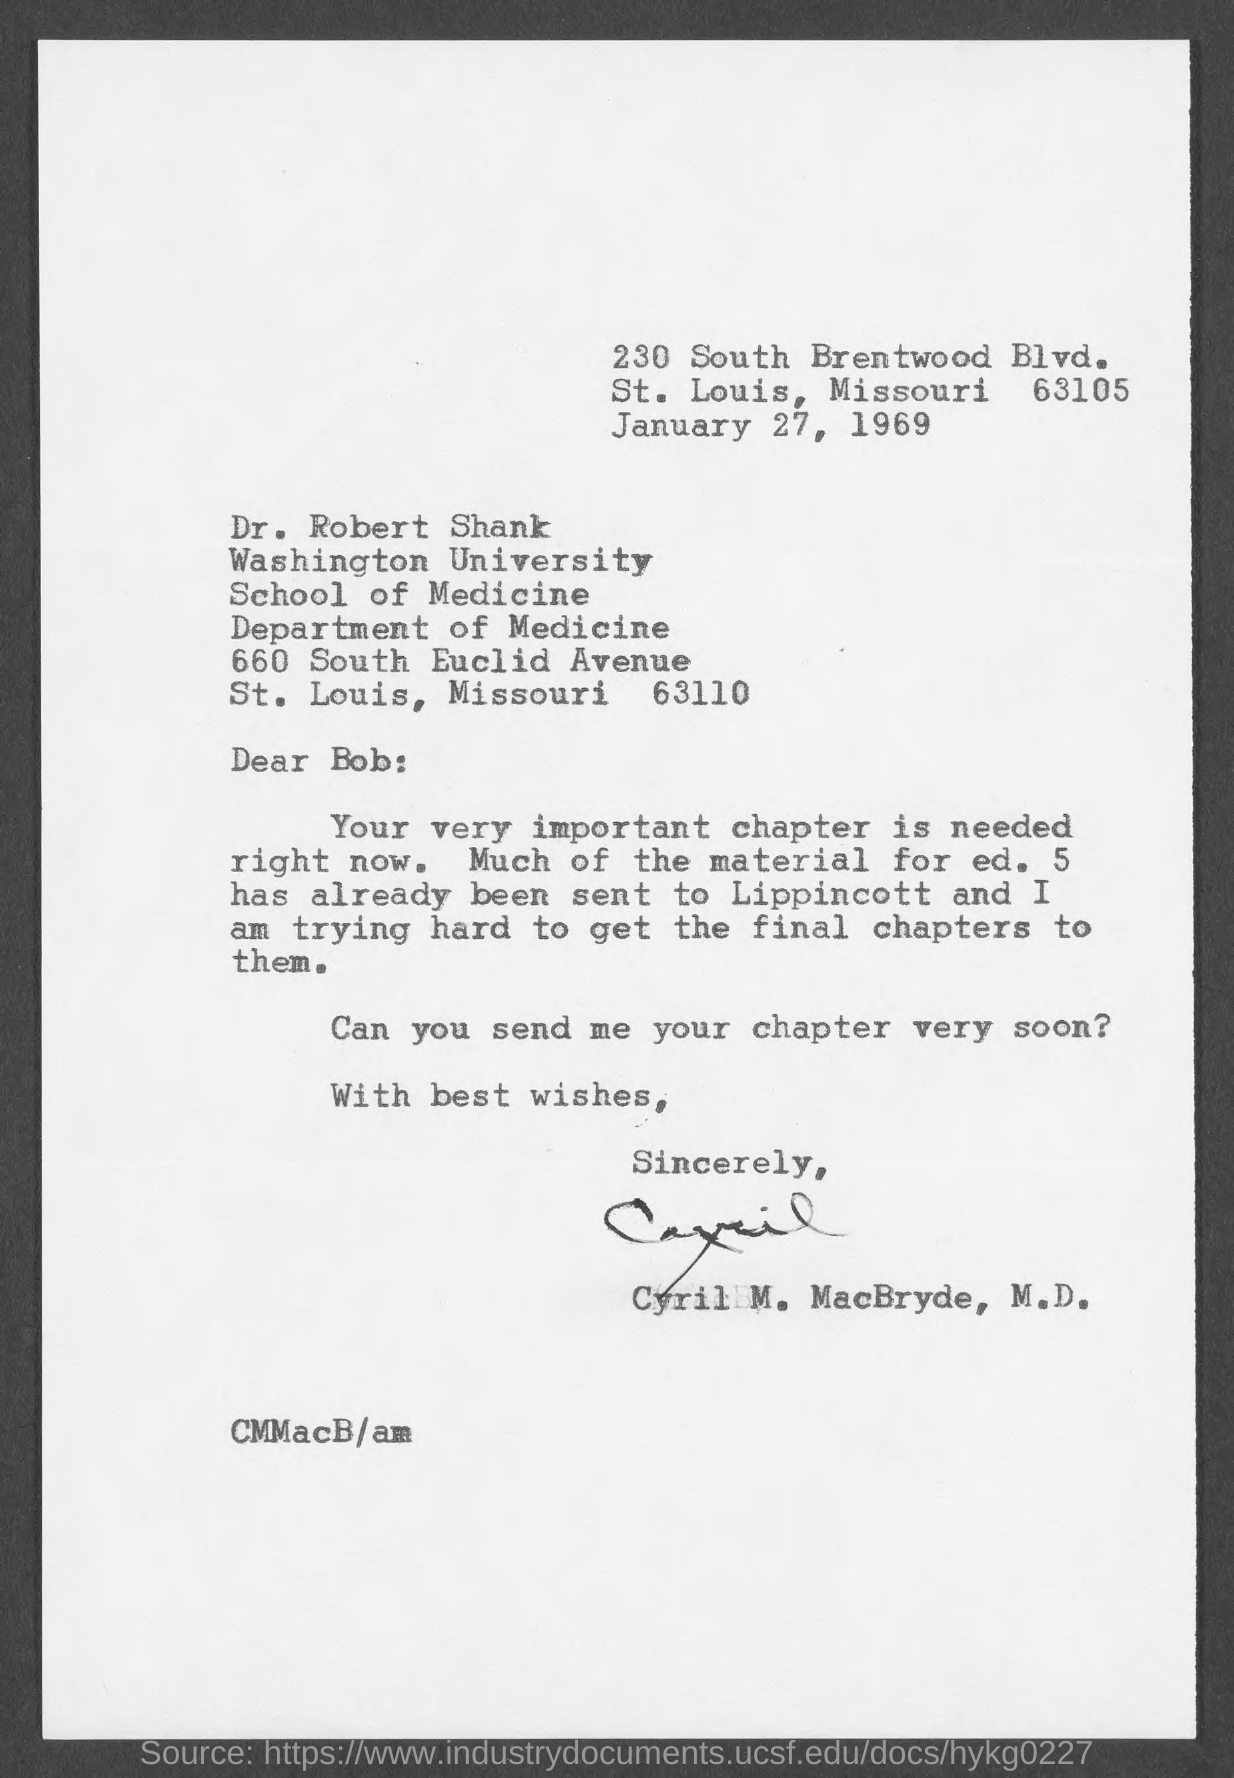What is the date mentioned in the given letter ?
Provide a succinct answer. January 27, 1969. Who's sign was there at the end of the letter ?
Give a very brief answer. Cyril M. MacBryde. 